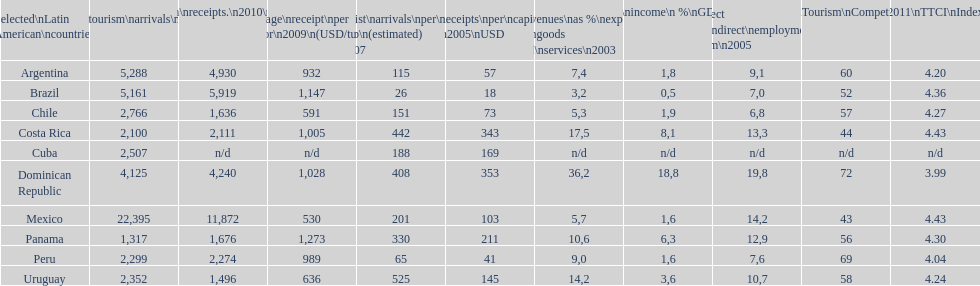What was the number of international tourists arriving in mexico in 2010 (in thousands)? 22,395. 